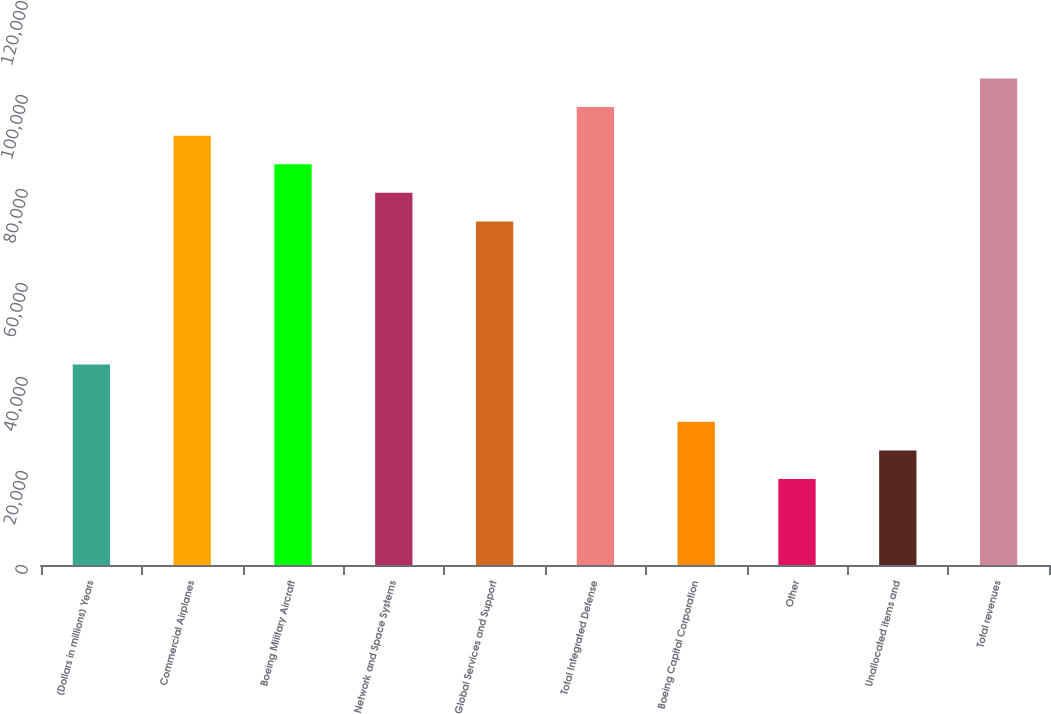Convert chart. <chart><loc_0><loc_0><loc_500><loc_500><bar_chart><fcel>(Dollars in millions) Years<fcel>Commercial Airplanes<fcel>Boeing Military Aircraft<fcel>Network and Space Systems<fcel>Global Services and Support<fcel>Total Integrated Defense<fcel>Boeing Capital Corporation<fcel>Other<fcel>Unallocated items and<fcel>Total revenues<nl><fcel>42641.7<fcel>91354.5<fcel>85265.4<fcel>79176.3<fcel>73087.2<fcel>97443.6<fcel>30463.5<fcel>18285.3<fcel>24374.4<fcel>103533<nl></chart> 